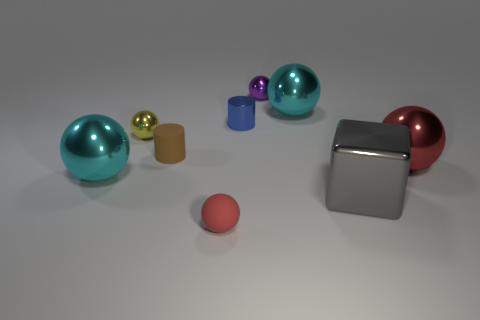What is the material of the tiny thing that is in front of the big cyan metal sphere in front of the small cylinder in front of the metallic cylinder? The material of the small object in front of the big cyan metal sphere, which itself is in front of a small cylinder and a metallic cylinder, appears to be rubber based on its matte texture and size that suggests it could be a small rubber ball. 